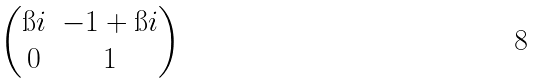<formula> <loc_0><loc_0><loc_500><loc_500>\begin{pmatrix} \i i & - 1 + \i i \\ 0 & 1 \end{pmatrix}</formula> 